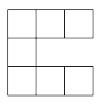What are other interesting properties or patterns that can be observed when arranging squares in different formations? When arranging squares, the geometric properties like symmetry, perimeter, and area can vary significantly. For example, arranging squares in a line or a square formation offers regular and predictable changes, whereas more complex shapes like letters or zigzags introduce irregular perimeter to area ratios. These patterns are not only visually compelling but also pose interesting challenges for mathematical exploration, such as computing perimeters and areas efficiently. 